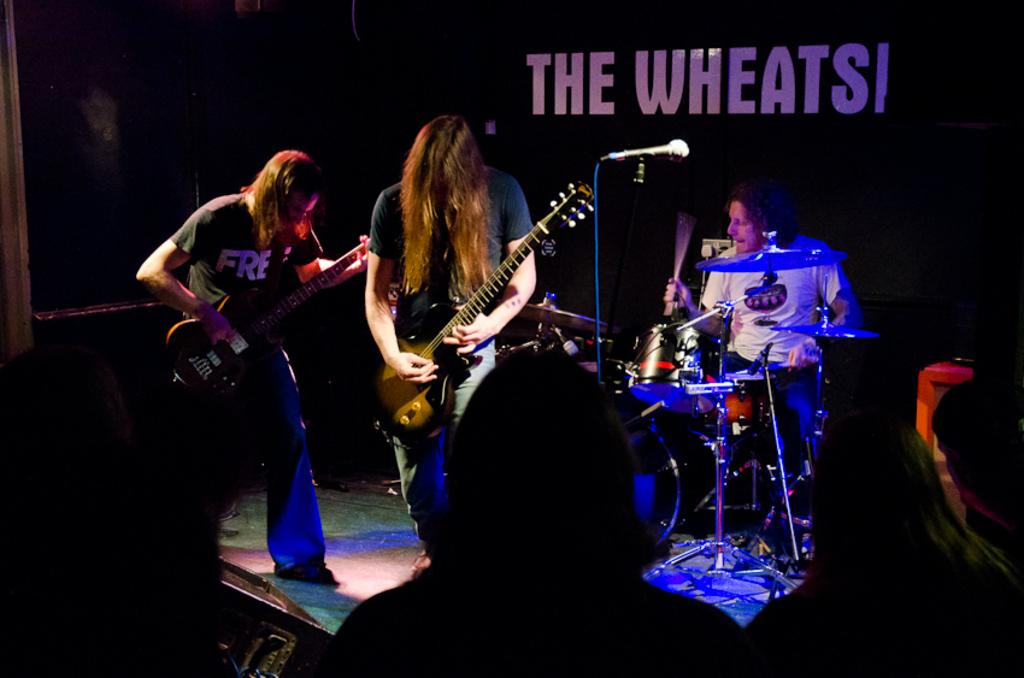What are the people in the image doing? The people in the image are playing musical instruments. What else can be seen in the image besides the people playing instruments? There is a banner visible in the image. What type of shoe is the representative wearing in the image? There is no representative or shoe present in the image. How does the sail contribute to the musical performance in the image? There is no sail present in the image; the people are playing musical instruments without any sail involvement. 